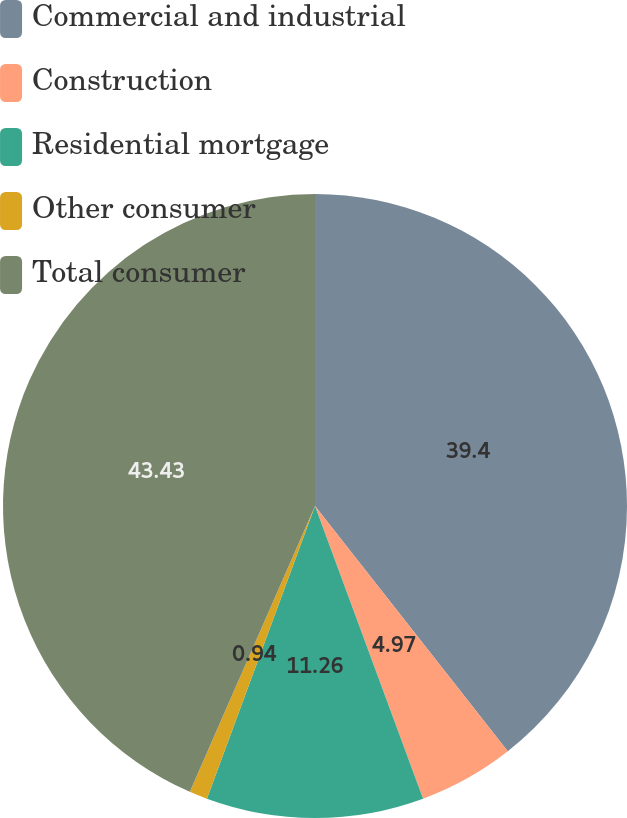Convert chart to OTSL. <chart><loc_0><loc_0><loc_500><loc_500><pie_chart><fcel>Commercial and industrial<fcel>Construction<fcel>Residential mortgage<fcel>Other consumer<fcel>Total consumer<nl><fcel>39.4%<fcel>4.97%<fcel>11.26%<fcel>0.94%<fcel>43.43%<nl></chart> 